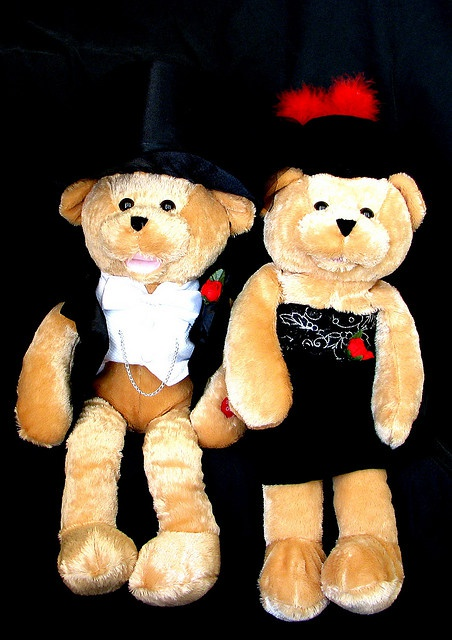Describe the objects in this image and their specific colors. I can see teddy bear in black, tan, orange, and beige tones, teddy bear in black, ivory, and tan tones, and tie in black, white, and lightblue tones in this image. 